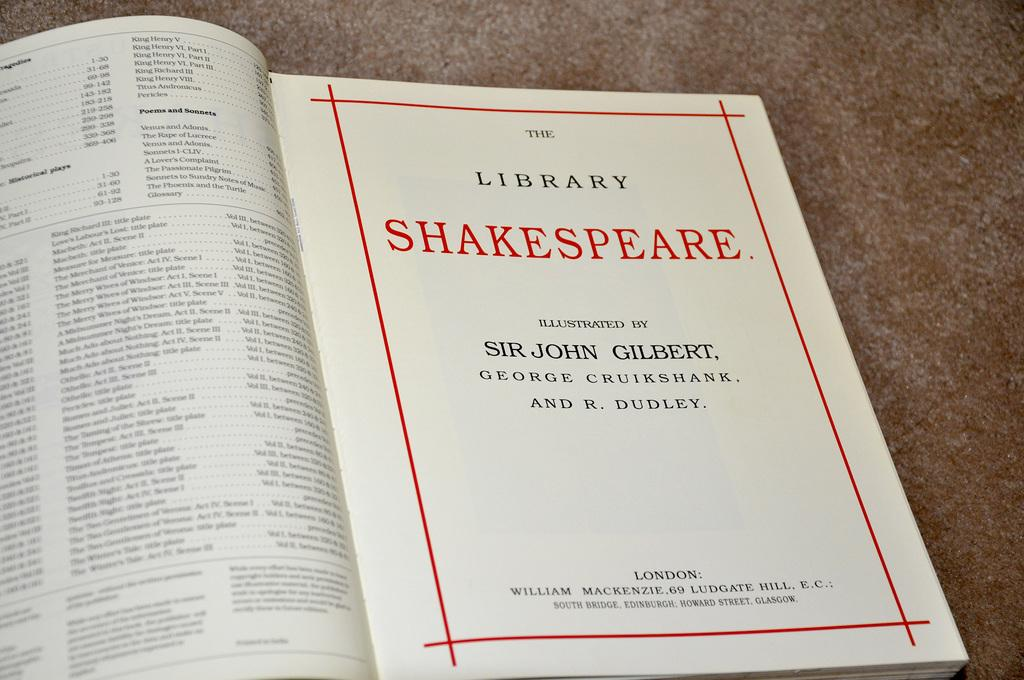<image>
Write a terse but informative summary of the picture. A book about Shakespeare is open to the title page. 